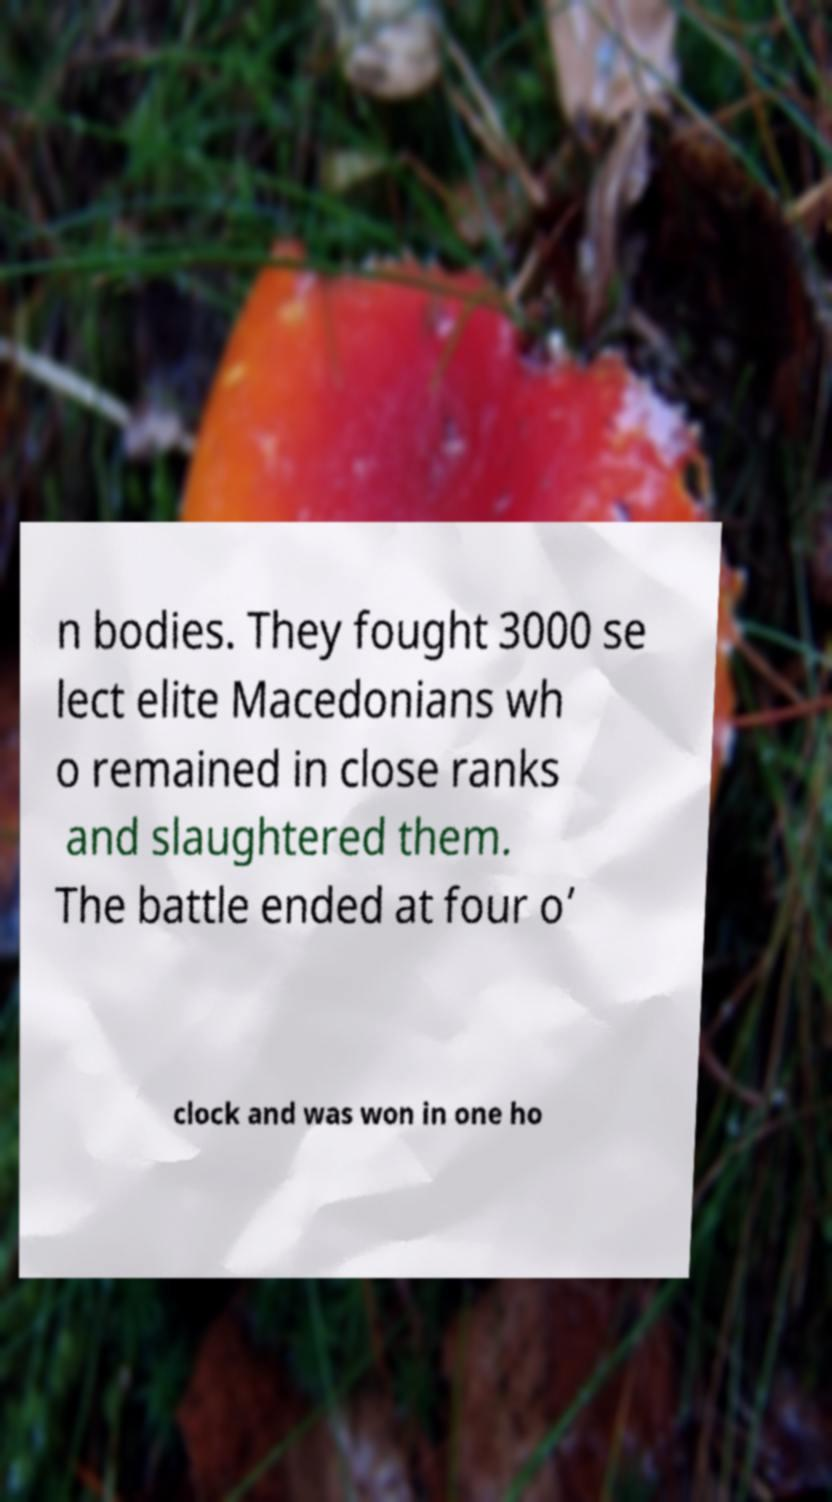What messages or text are displayed in this image? I need them in a readable, typed format. n bodies. They fought 3000 se lect elite Macedonians wh o remained in close ranks and slaughtered them. The battle ended at four o’ clock and was won in one ho 